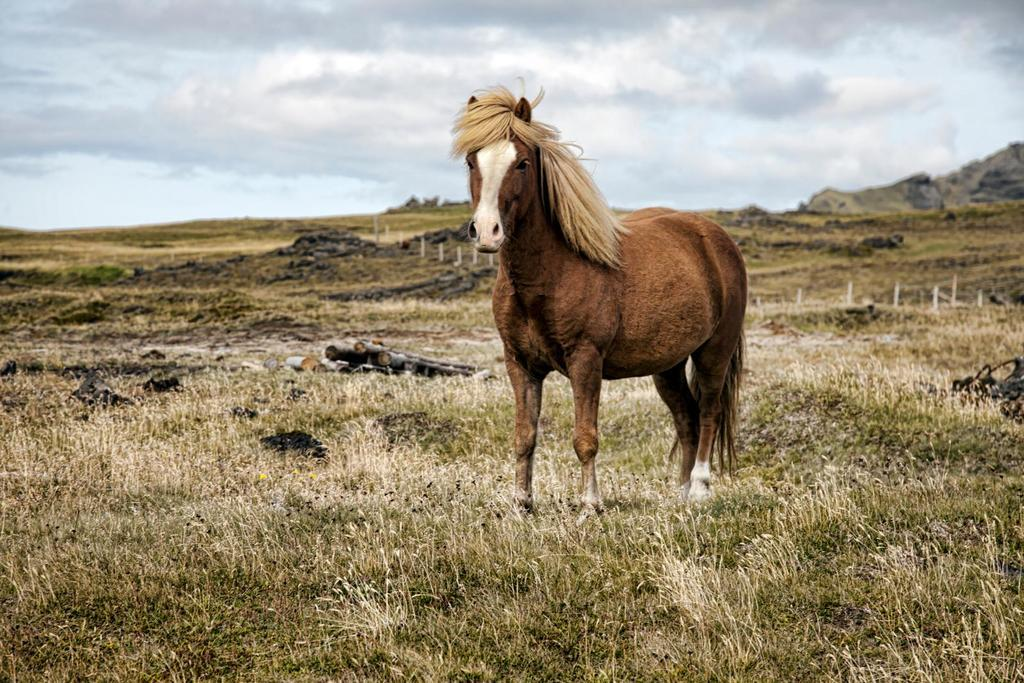What animal is standing on the grass in the image? There is a horse standing on the grass in the image. What type of material is used for the logs visible in the image? The logs visible in the image are made of wood. What are the poles used for in the image? The purpose of the poles in the image is not specified, but they could be used for fencing or other structures. What type of landscape can be seen in the background of the image? Hills are visible in the background of the image. What is the weather like in the image? The sky is cloudy in the image, indicating a potentially overcast or rainy day. How does the horse attempt to slip on the stream in the image? There is no stream present in the image, and the horse is not attempting to slip. 